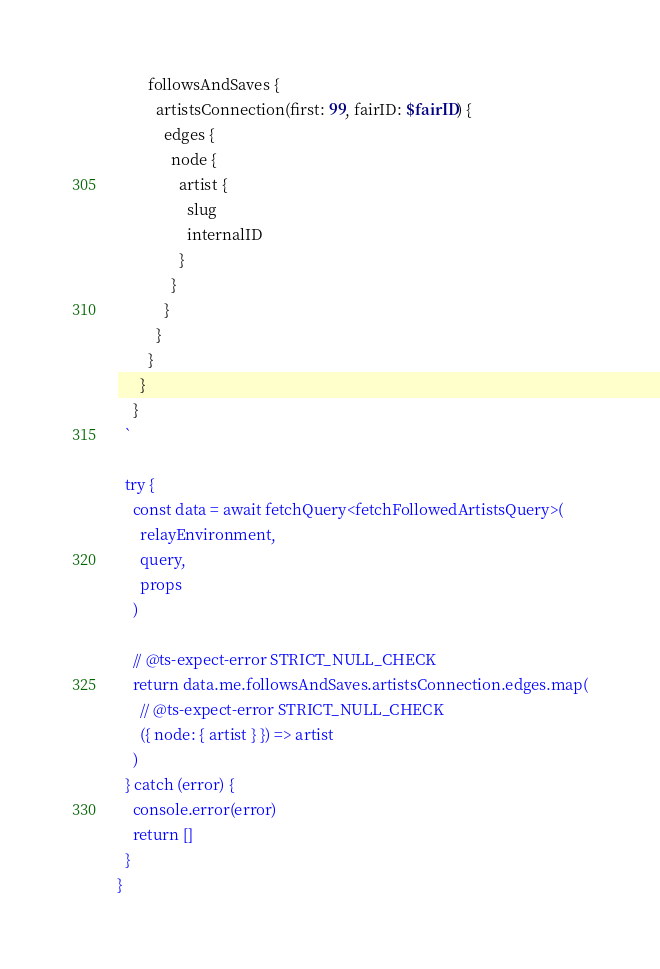Convert code to text. <code><loc_0><loc_0><loc_500><loc_500><_TypeScript_>        followsAndSaves {
          artistsConnection(first: 99, fairID: $fairID) {
            edges {
              node {
                artist {
                  slug
                  internalID
                }
              }
            }
          }
        }
      }
    }
  `

  try {
    const data = await fetchQuery<fetchFollowedArtistsQuery>(
      relayEnvironment,
      query,
      props
    )

    // @ts-expect-error STRICT_NULL_CHECK
    return data.me.followsAndSaves.artistsConnection.edges.map(
      // @ts-expect-error STRICT_NULL_CHECK
      ({ node: { artist } }) => artist
    )
  } catch (error) {
    console.error(error)
    return []
  }
}
</code> 